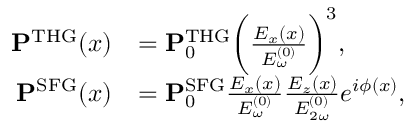Convert formula to latex. <formula><loc_0><loc_0><loc_500><loc_500>\begin{array} { r l } { P ^ { T H G } ( x ) } & { = P _ { 0 } ^ { T H G } \left ( \frac { E _ { x } ( x ) } { E _ { \omega } ^ { ( 0 ) } } \right ) ^ { 3 } , } \\ { P ^ { S F G } ( x ) } & { = P _ { 0 } ^ { S F G } \frac { E _ { x } ( x ) } { E _ { \omega } ^ { ( 0 ) } } \frac { E _ { z } ( x ) } { E _ { 2 \omega } ^ { ( 0 ) } } e ^ { i \phi ( x ) } , } \end{array}</formula> 